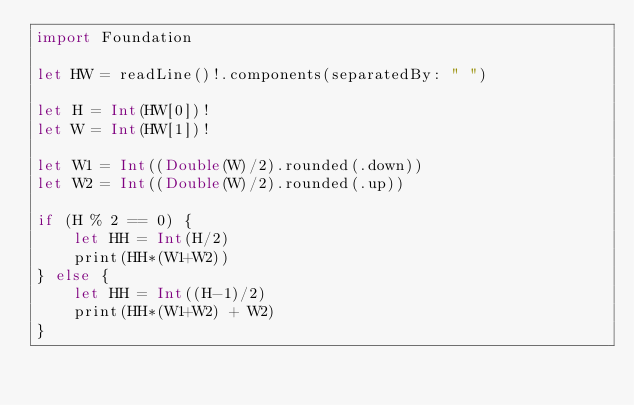Convert code to text. <code><loc_0><loc_0><loc_500><loc_500><_Swift_>import Foundation

let HW = readLine()!.components(separatedBy: " ")

let H = Int(HW[0])!
let W = Int(HW[1])!

let W1 = Int((Double(W)/2).rounded(.down))
let W2 = Int((Double(W)/2).rounded(.up))

if (H % 2 == 0) {
    let HH = Int(H/2)
    print(HH*(W1+W2))
} else {
    let HH = Int((H-1)/2)
    print(HH*(W1+W2) + W2)
}
</code> 